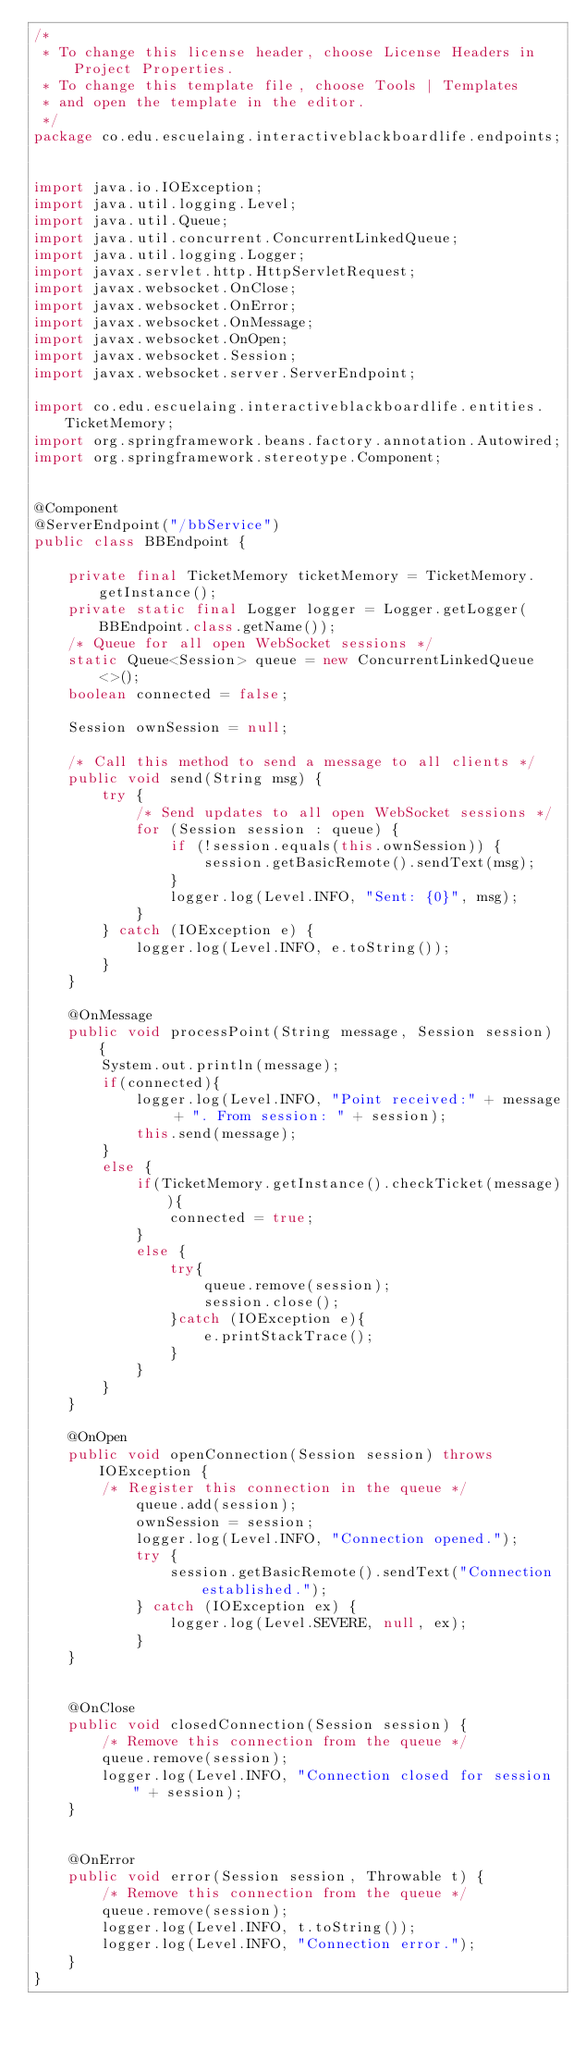<code> <loc_0><loc_0><loc_500><loc_500><_Java_>/*
 * To change this license header, choose License Headers in Project Properties.
 * To change this template file, choose Tools | Templates
 * and open the template in the editor.
 */
package co.edu.escuelaing.interactiveblackboardlife.endpoints;


import java.io.IOException;
import java.util.logging.Level;
import java.util.Queue;
import java.util.concurrent.ConcurrentLinkedQueue;
import java.util.logging.Logger;
import javax.servlet.http.HttpServletRequest;
import javax.websocket.OnClose;
import javax.websocket.OnError;
import javax.websocket.OnMessage;
import javax.websocket.OnOpen;
import javax.websocket.Session;
import javax.websocket.server.ServerEndpoint;

import co.edu.escuelaing.interactiveblackboardlife.entities.TicketMemory;
import org.springframework.beans.factory.annotation.Autowired;
import org.springframework.stereotype.Component;


@Component
@ServerEndpoint("/bbService")
public class BBEndpoint {

    private final TicketMemory ticketMemory = TicketMemory.getInstance();
    private static final Logger logger = Logger.getLogger(BBEndpoint.class.getName());
    /* Queue for all open WebSocket sessions */
    static Queue<Session> queue = new ConcurrentLinkedQueue<>();
    boolean connected = false;

    Session ownSession = null;

    /* Call this method to send a message to all clients */
    public void send(String msg) {
        try {
            /* Send updates to all open WebSocket sessions */
            for (Session session : queue) {
                if (!session.equals(this.ownSession)) {
                    session.getBasicRemote().sendText(msg);
                }
                logger.log(Level.INFO, "Sent: {0}", msg);
            }
        } catch (IOException e) {
            logger.log(Level.INFO, e.toString());
        }
    }

    @OnMessage
    public void processPoint(String message, Session session) {
        System.out.println(message);
        if(connected){
            logger.log(Level.INFO, "Point received:" + message + ". From session: " + session);
            this.send(message);
        }
        else {
            if(TicketMemory.getInstance().checkTicket(message)){
                connected = true;
            }
            else {
                try{
                    queue.remove(session);
                    session.close();
                }catch (IOException e){
                    e.printStackTrace();
                }
            }
        }
    }

    @OnOpen
    public void openConnection(Session session) throws IOException {
        /* Register this connection in the queue */
            queue.add(session);
            ownSession = session;
            logger.log(Level.INFO, "Connection opened.");
            try {
                session.getBasicRemote().sendText("Connection established.");
            } catch (IOException ex) {
                logger.log(Level.SEVERE, null, ex);
            }
    }


    @OnClose
    public void closedConnection(Session session) {
        /* Remove this connection from the queue */
        queue.remove(session);
        logger.log(Level.INFO, "Connection closed for session " + session);
    }


    @OnError
    public void error(Session session, Throwable t) {
        /* Remove this connection from the queue */
        queue.remove(session);
        logger.log(Level.INFO, t.toString());
        logger.log(Level.INFO, "Connection error.");
    }
}</code> 